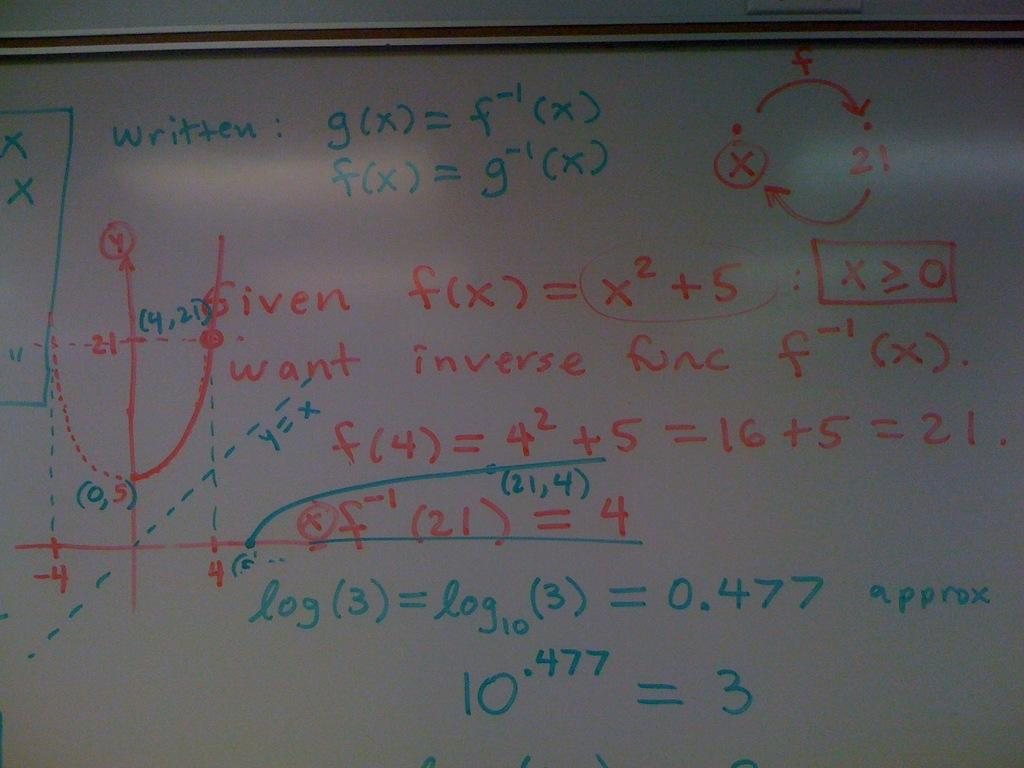<image>
Offer a succinct explanation of the picture presented. A series of formulas on a whiteboard one of wich is g(x) = f-1(x). 